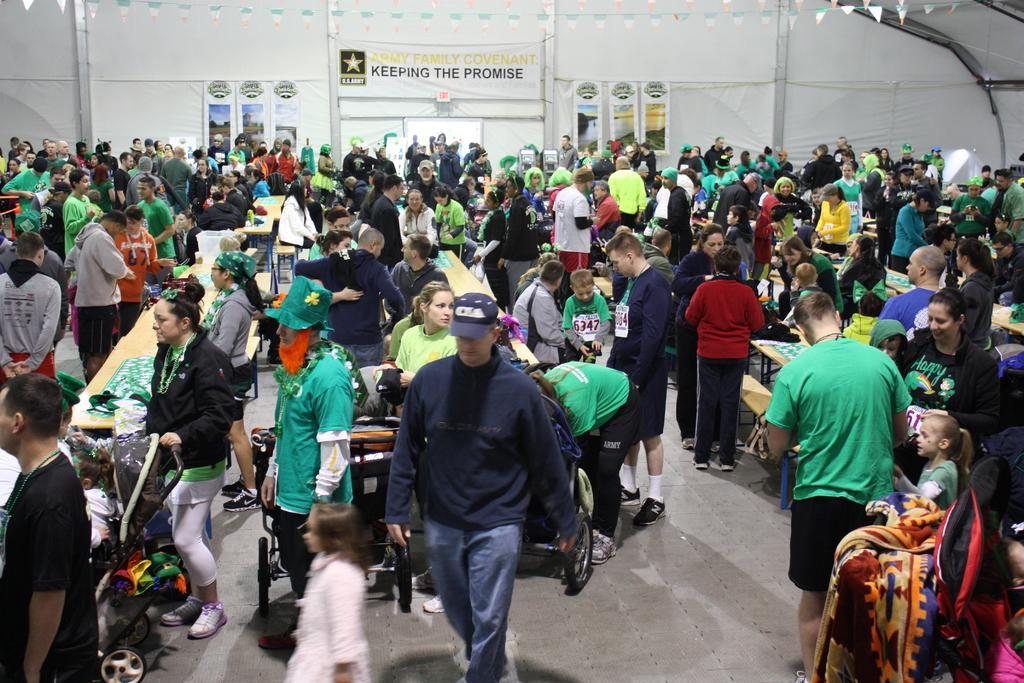How would you summarize this image in a sentence or two? In this image there are few person standing on the floor having few baby trolleys on it. There are few tables on the floor. Background there are few banners attached to the wall. Left side there is a woman wearing a black jacket is holding a baby trolley. A kid is in the baby trolley. There are few objects on the tables. 